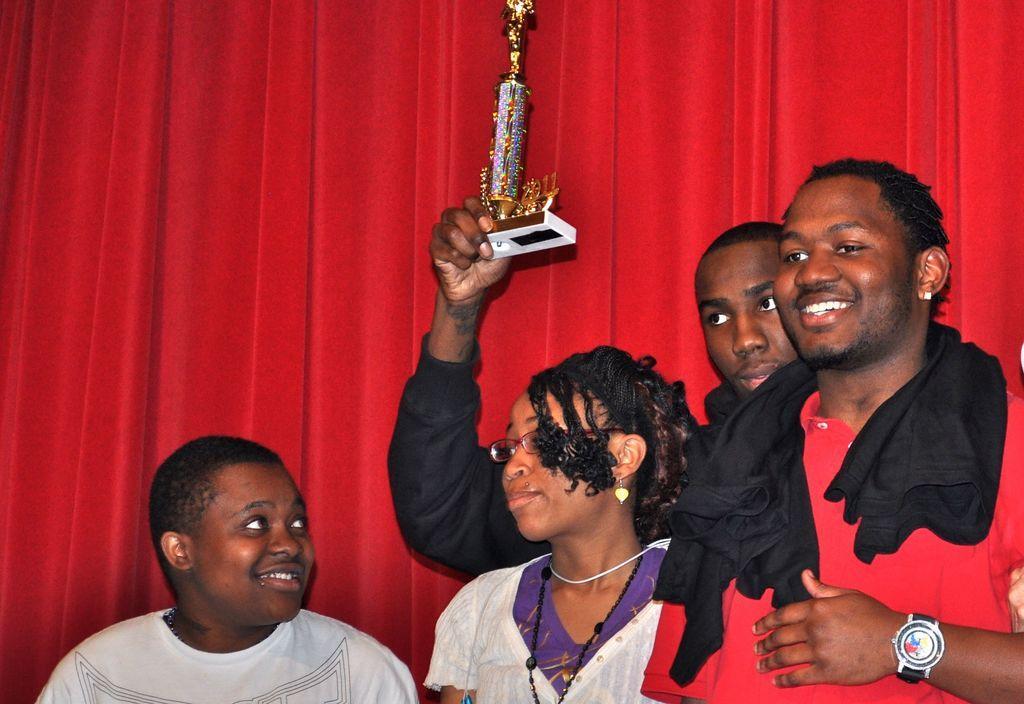Could you give a brief overview of what you see in this image? In this picture I can observe four members. Two of them are smiling. One of them is holding a trophy in his hand. I can observe a girl in the middle of the picture. In the background there is a red color curtain. 